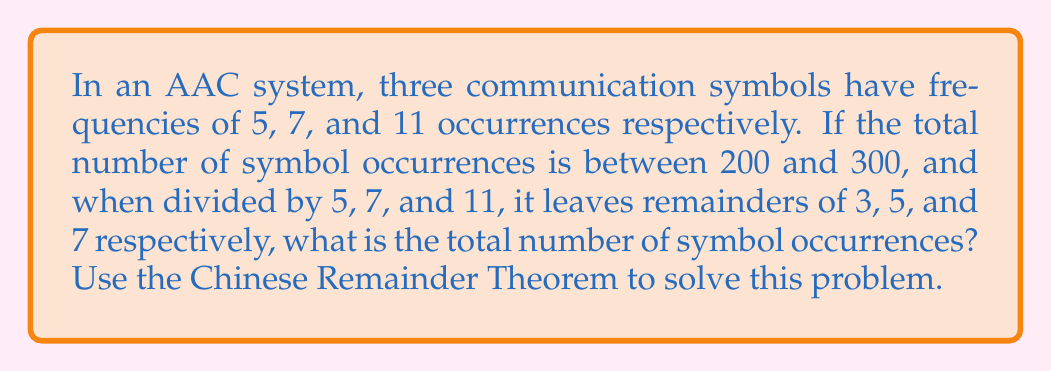Give your solution to this math problem. Let's solve this step-by-step using the Chinese Remainder Theorem (CRT):

1) We have three congruences:
   $x \equiv 3 \pmod{5}$
   $x \equiv 5 \pmod{7}$
   $x \equiv 7 \pmod{11}$

2) Calculate $N = 5 \cdot 7 \cdot 11 = 385$

3) Calculate $N_i$ for each modulus:
   $N_1 = N/5 = 77$
   $N_2 = N/7 = 55$
   $N_3 = N/11 = 35$

4) Find the modular multiplicative inverses:
   $77^{-1} \equiv 3 \pmod{5}$
   $55^{-1} \equiv 6 \pmod{7}$
   $35^{-1} \equiv 2 \pmod{11}$

5) Calculate the solution:
   $x = (3 \cdot 77 \cdot 3 + 5 \cdot 55 \cdot 6 + 7 \cdot 35 \cdot 2) \pmod{385}$
   $x = (693 + 1650 + 490) \pmod{385}$
   $x = 2833 \pmod{385}$
   $x = 238$

6) Verify that 238 is between 200 and 300.

Therefore, the total number of symbol occurrences is 238.
Answer: 238 